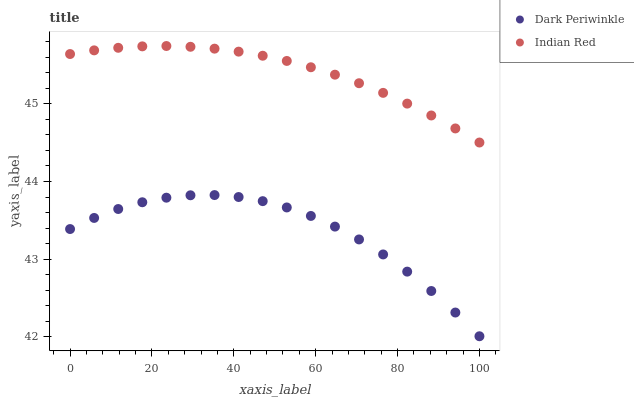Does Dark Periwinkle have the minimum area under the curve?
Answer yes or no. Yes. Does Indian Red have the maximum area under the curve?
Answer yes or no. Yes. Does Indian Red have the minimum area under the curve?
Answer yes or no. No. Is Indian Red the smoothest?
Answer yes or no. Yes. Is Dark Periwinkle the roughest?
Answer yes or no. Yes. Is Indian Red the roughest?
Answer yes or no. No. Does Dark Periwinkle have the lowest value?
Answer yes or no. Yes. Does Indian Red have the lowest value?
Answer yes or no. No. Does Indian Red have the highest value?
Answer yes or no. Yes. Is Dark Periwinkle less than Indian Red?
Answer yes or no. Yes. Is Indian Red greater than Dark Periwinkle?
Answer yes or no. Yes. Does Dark Periwinkle intersect Indian Red?
Answer yes or no. No. 